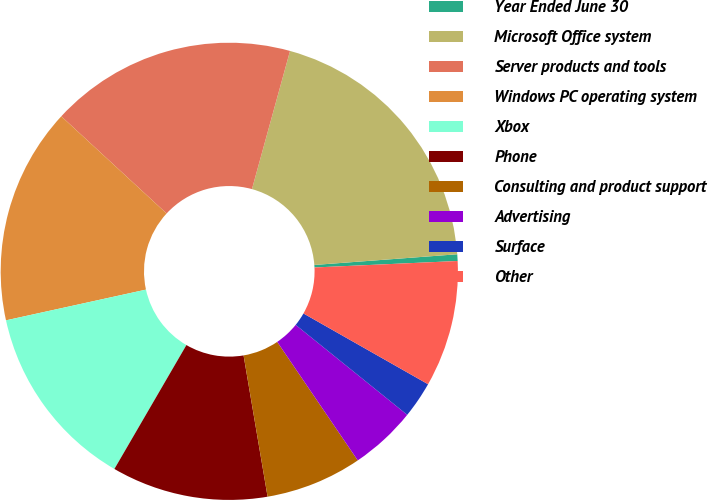<chart> <loc_0><loc_0><loc_500><loc_500><pie_chart><fcel>Year Ended June 30<fcel>Microsoft Office system<fcel>Server products and tools<fcel>Windows PC operating system<fcel>Xbox<fcel>Phone<fcel>Consulting and product support<fcel>Advertising<fcel>Surface<fcel>Other<nl><fcel>0.47%<fcel>19.53%<fcel>17.42%<fcel>15.3%<fcel>13.18%<fcel>11.06%<fcel>6.82%<fcel>4.7%<fcel>2.58%<fcel>8.94%<nl></chart> 